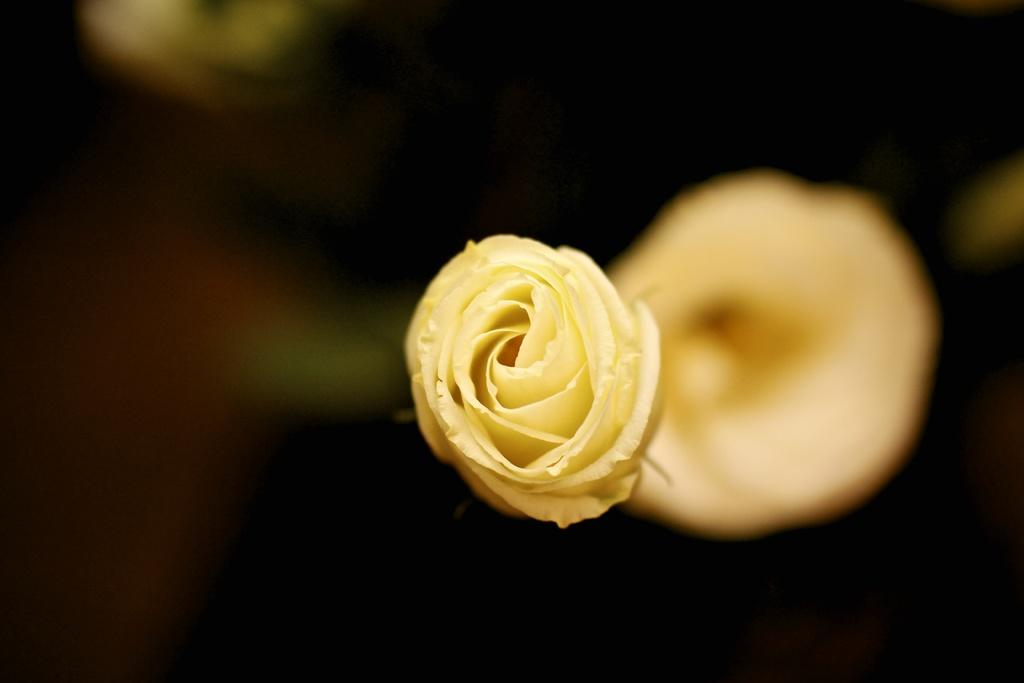What is the main subject of the image? There is a flower in the image. What color is the flower? The flower is yellow in color. How would you describe the background of the image? The background of the image is blurry and black and yellow in color. How many fangs can be seen on the flower in the image? There are no fangs present on the flower in the image, as flowers do not have fangs. Is there a woman in the image? There is no mention of a woman in the provided facts, and therefore we cannot confirm her presence in the image. 